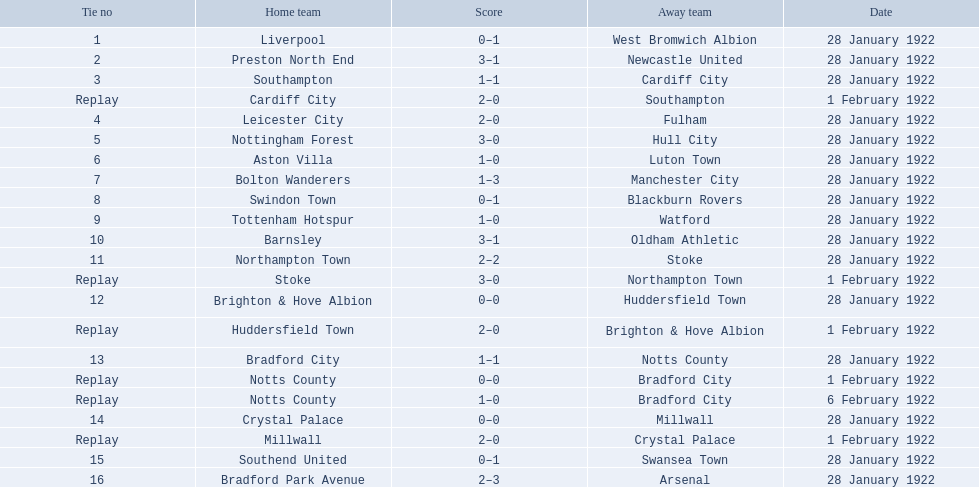Write the full table. {'header': ['Tie no', 'Home team', 'Score', 'Away team', 'Date'], 'rows': [['1', 'Liverpool', '0–1', 'West Bromwich Albion', '28 January 1922'], ['2', 'Preston North End', '3–1', 'Newcastle United', '28 January 1922'], ['3', 'Southampton', '1–1', 'Cardiff City', '28 January 1922'], ['Replay', 'Cardiff City', '2–0', 'Southampton', '1 February 1922'], ['4', 'Leicester City', '2–0', 'Fulham', '28 January 1922'], ['5', 'Nottingham Forest', '3–0', 'Hull City', '28 January 1922'], ['6', 'Aston Villa', '1–0', 'Luton Town', '28 January 1922'], ['7', 'Bolton Wanderers', '1–3', 'Manchester City', '28 January 1922'], ['8', 'Swindon Town', '0–1', 'Blackburn Rovers', '28 January 1922'], ['9', 'Tottenham Hotspur', '1–0', 'Watford', '28 January 1922'], ['10', 'Barnsley', '3–1', 'Oldham Athletic', '28 January 1922'], ['11', 'Northampton Town', '2–2', 'Stoke', '28 January 1922'], ['Replay', 'Stoke', '3–0', 'Northampton Town', '1 February 1922'], ['12', 'Brighton & Hove Albion', '0–0', 'Huddersfield Town', '28 January 1922'], ['Replay', 'Huddersfield Town', '2–0', 'Brighton & Hove Albion', '1 February 1922'], ['13', 'Bradford City', '1–1', 'Notts County', '28 January 1922'], ['Replay', 'Notts County', '0–0', 'Bradford City', '1 February 1922'], ['Replay', 'Notts County', '1–0', 'Bradford City', '6 February 1922'], ['14', 'Crystal Palace', '0–0', 'Millwall', '28 January 1922'], ['Replay', 'Millwall', '2–0', 'Crystal Palace', '1 February 1922'], ['15', 'Southend United', '0–1', 'Swansea Town', '28 January 1922'], ['16', 'Bradford Park Avenue', '2–3', 'Arsenal', '28 January 1922']]} How did the aston villa game end in terms of score? 1–0. Is there another team that had a similar result? Tottenham Hotspur. 